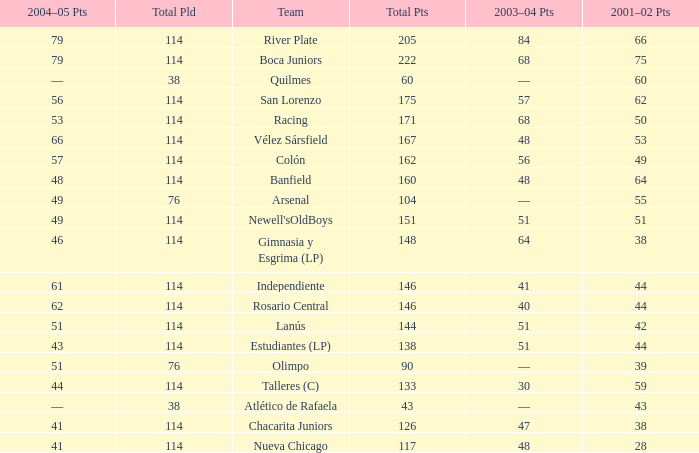Which Total Pts have a 2001–02 Pts smaller than 38? 117.0. 